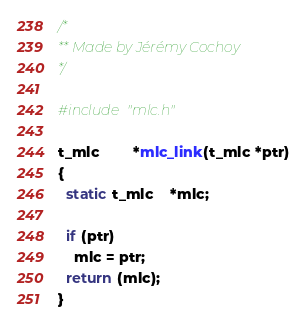<code> <loc_0><loc_0><loc_500><loc_500><_C_>/*
** Made by Jérémy Cochoy
*/

#include "mlc.h"

t_mlc		*mlc_link(t_mlc *ptr)
{
  static t_mlc	*mlc;

  if (ptr)
    mlc = ptr;
  return (mlc);
}
</code> 